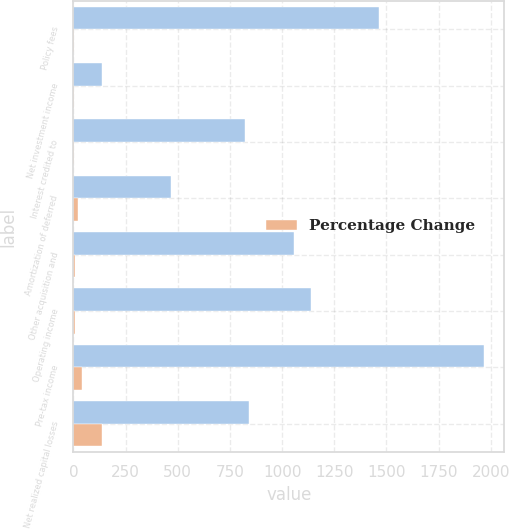Convert chart to OTSL. <chart><loc_0><loc_0><loc_500><loc_500><stacked_bar_chart><ecel><fcel>Policy fees<fcel>Net investment income<fcel>Interest credited to<fcel>Amortization of deferred<fcel>Other acquisition and<fcel>Operating income<fcel>Pre-tax income<fcel>Net realized capital losses<nl><fcel>nan<fcel>1465<fcel>136<fcel>822<fcel>467<fcel>1059<fcel>1136<fcel>1966<fcel>841<nl><fcel>Percentage Change<fcel>1<fcel>4<fcel>3<fcel>20<fcel>6<fcel>9<fcel>42<fcel>136<nl></chart> 